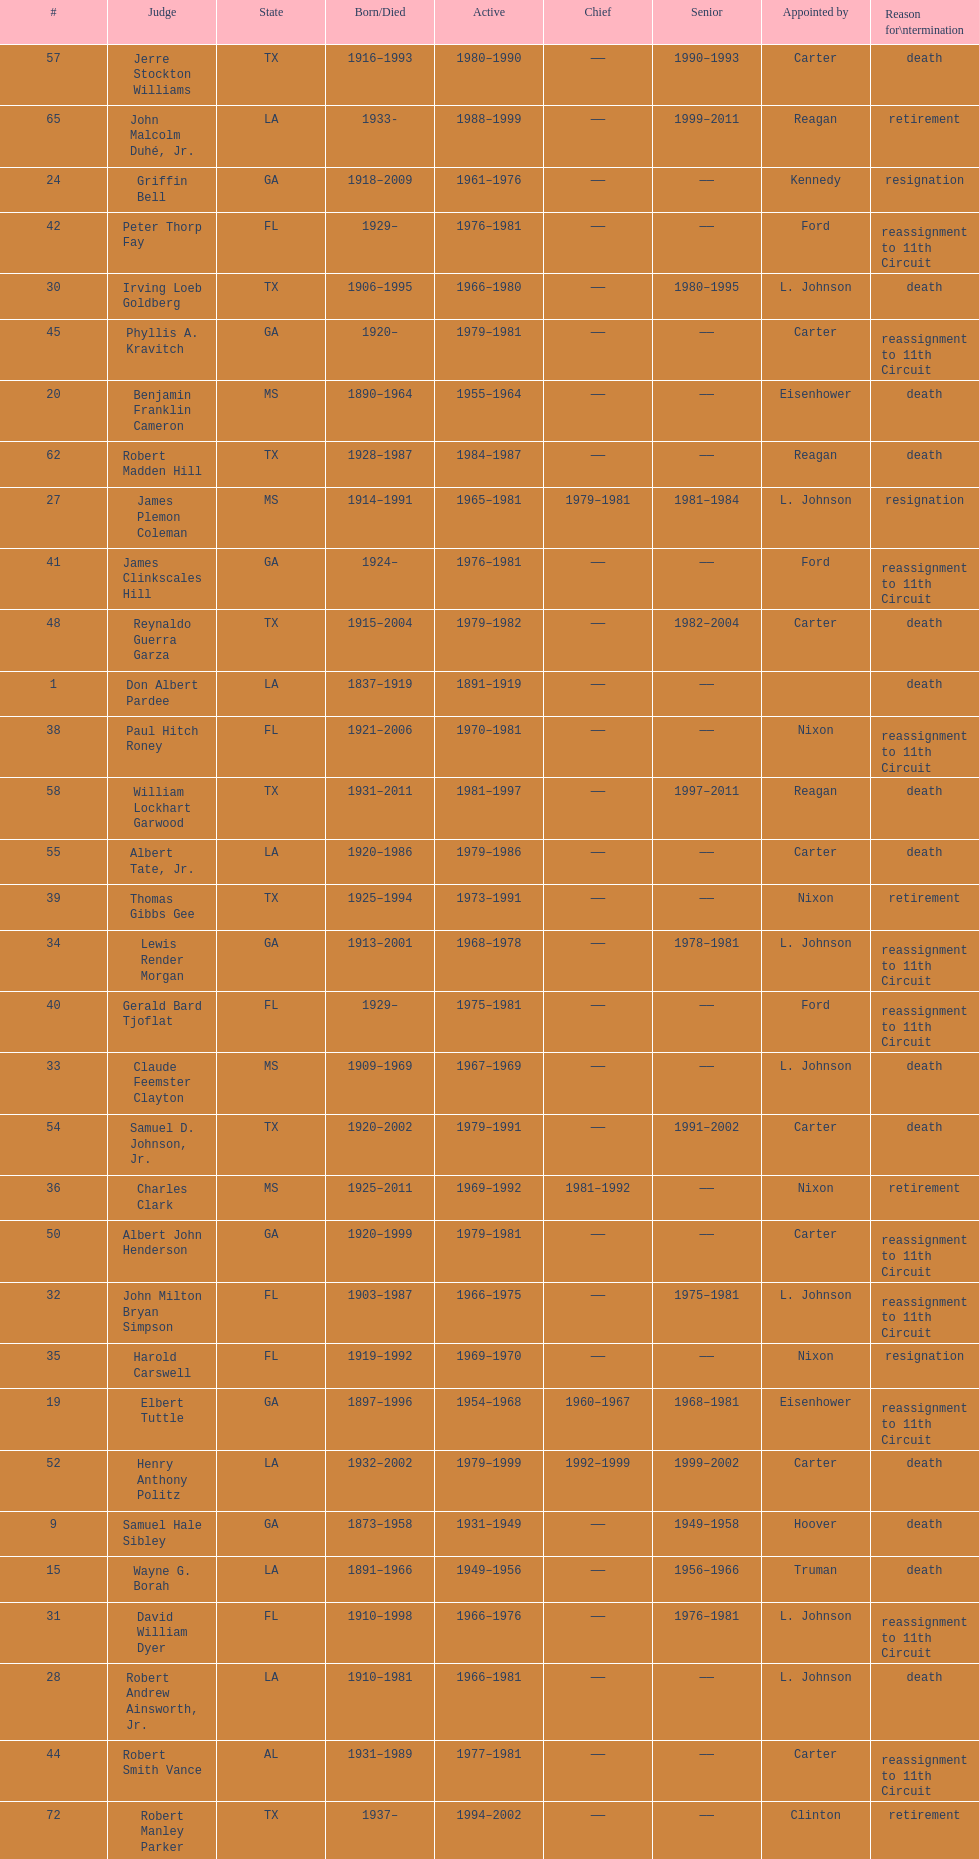Who was the next judge to resign after alexander campbell king? Griffin Bell. 